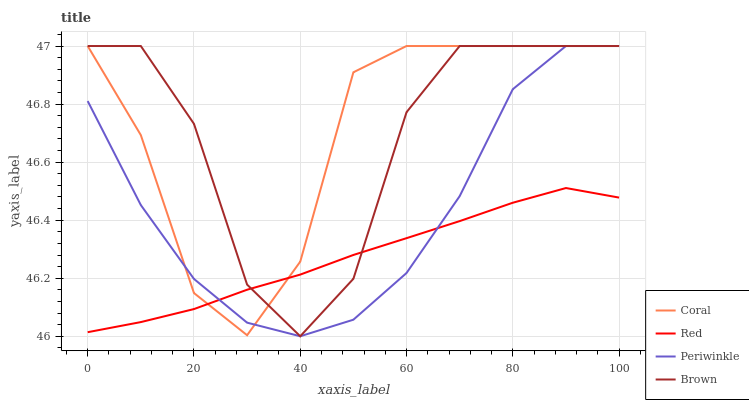Does Red have the minimum area under the curve?
Answer yes or no. Yes. Does Periwinkle have the minimum area under the curve?
Answer yes or no. No. Does Periwinkle have the maximum area under the curve?
Answer yes or no. No. Is Brown the roughest?
Answer yes or no. Yes. Is Coral the smoothest?
Answer yes or no. No. Is Coral the roughest?
Answer yes or no. No. Does Coral have the lowest value?
Answer yes or no. No. Does Red have the highest value?
Answer yes or no. No. 